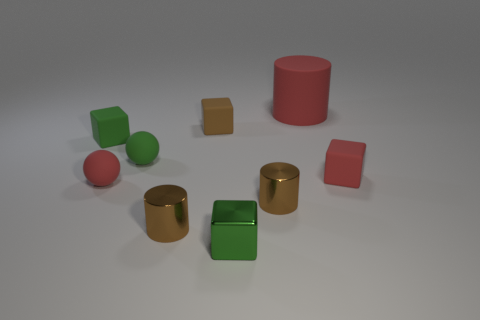The large thing that is the same material as the small red block is what color?
Provide a succinct answer. Red. Is the number of green balls greater than the number of tiny brown shiny cylinders?
Make the answer very short. No. What number of objects are either small cylinders that are on the right side of the tiny shiny cube or tiny brown rubber objects?
Your response must be concise. 2. Are there any green metallic things that have the same size as the brown rubber object?
Provide a short and direct response. Yes. Is the number of red cubes less than the number of small red matte things?
Make the answer very short. Yes. How many blocks are brown rubber objects or brown metallic objects?
Your answer should be compact. 1. What number of small rubber spheres are the same color as the large object?
Your response must be concise. 1. There is a brown object that is in front of the small red block and to the left of the tiny green metal object; what size is it?
Your answer should be very brief. Small. Are there fewer red cubes to the right of the green shiny cube than small objects?
Offer a very short reply. Yes. Do the small green ball and the small red sphere have the same material?
Offer a very short reply. Yes. 